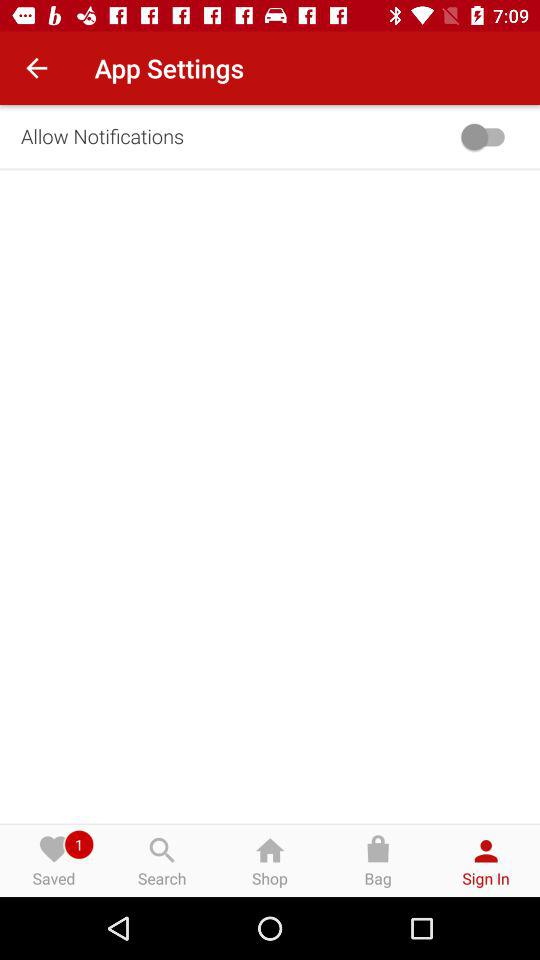What is the status of "Allow Notifications"? The status is "off". 